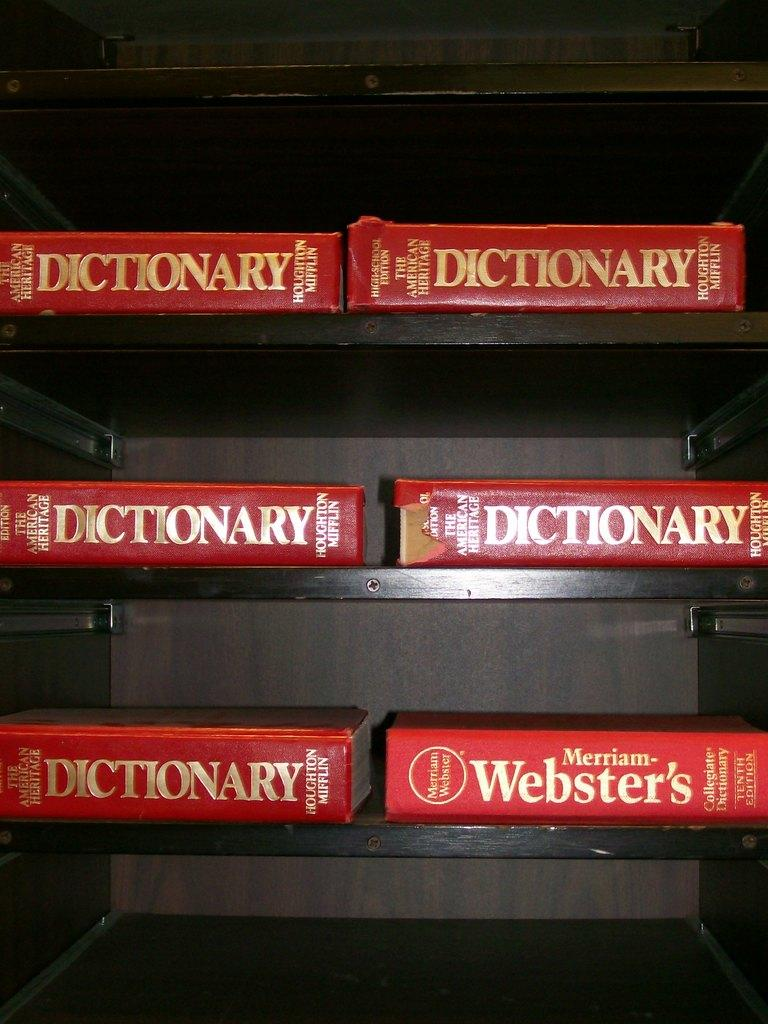<image>
Render a clear and concise summary of the photo. Six red dictionaries are stacked neatly on shelves. 